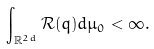Convert formula to latex. <formula><loc_0><loc_0><loc_500><loc_500>\int _ { \mathbb { R } ^ { 2 d } } \mathcal { R } ( q ) d \mu _ { 0 } < \infty .</formula> 